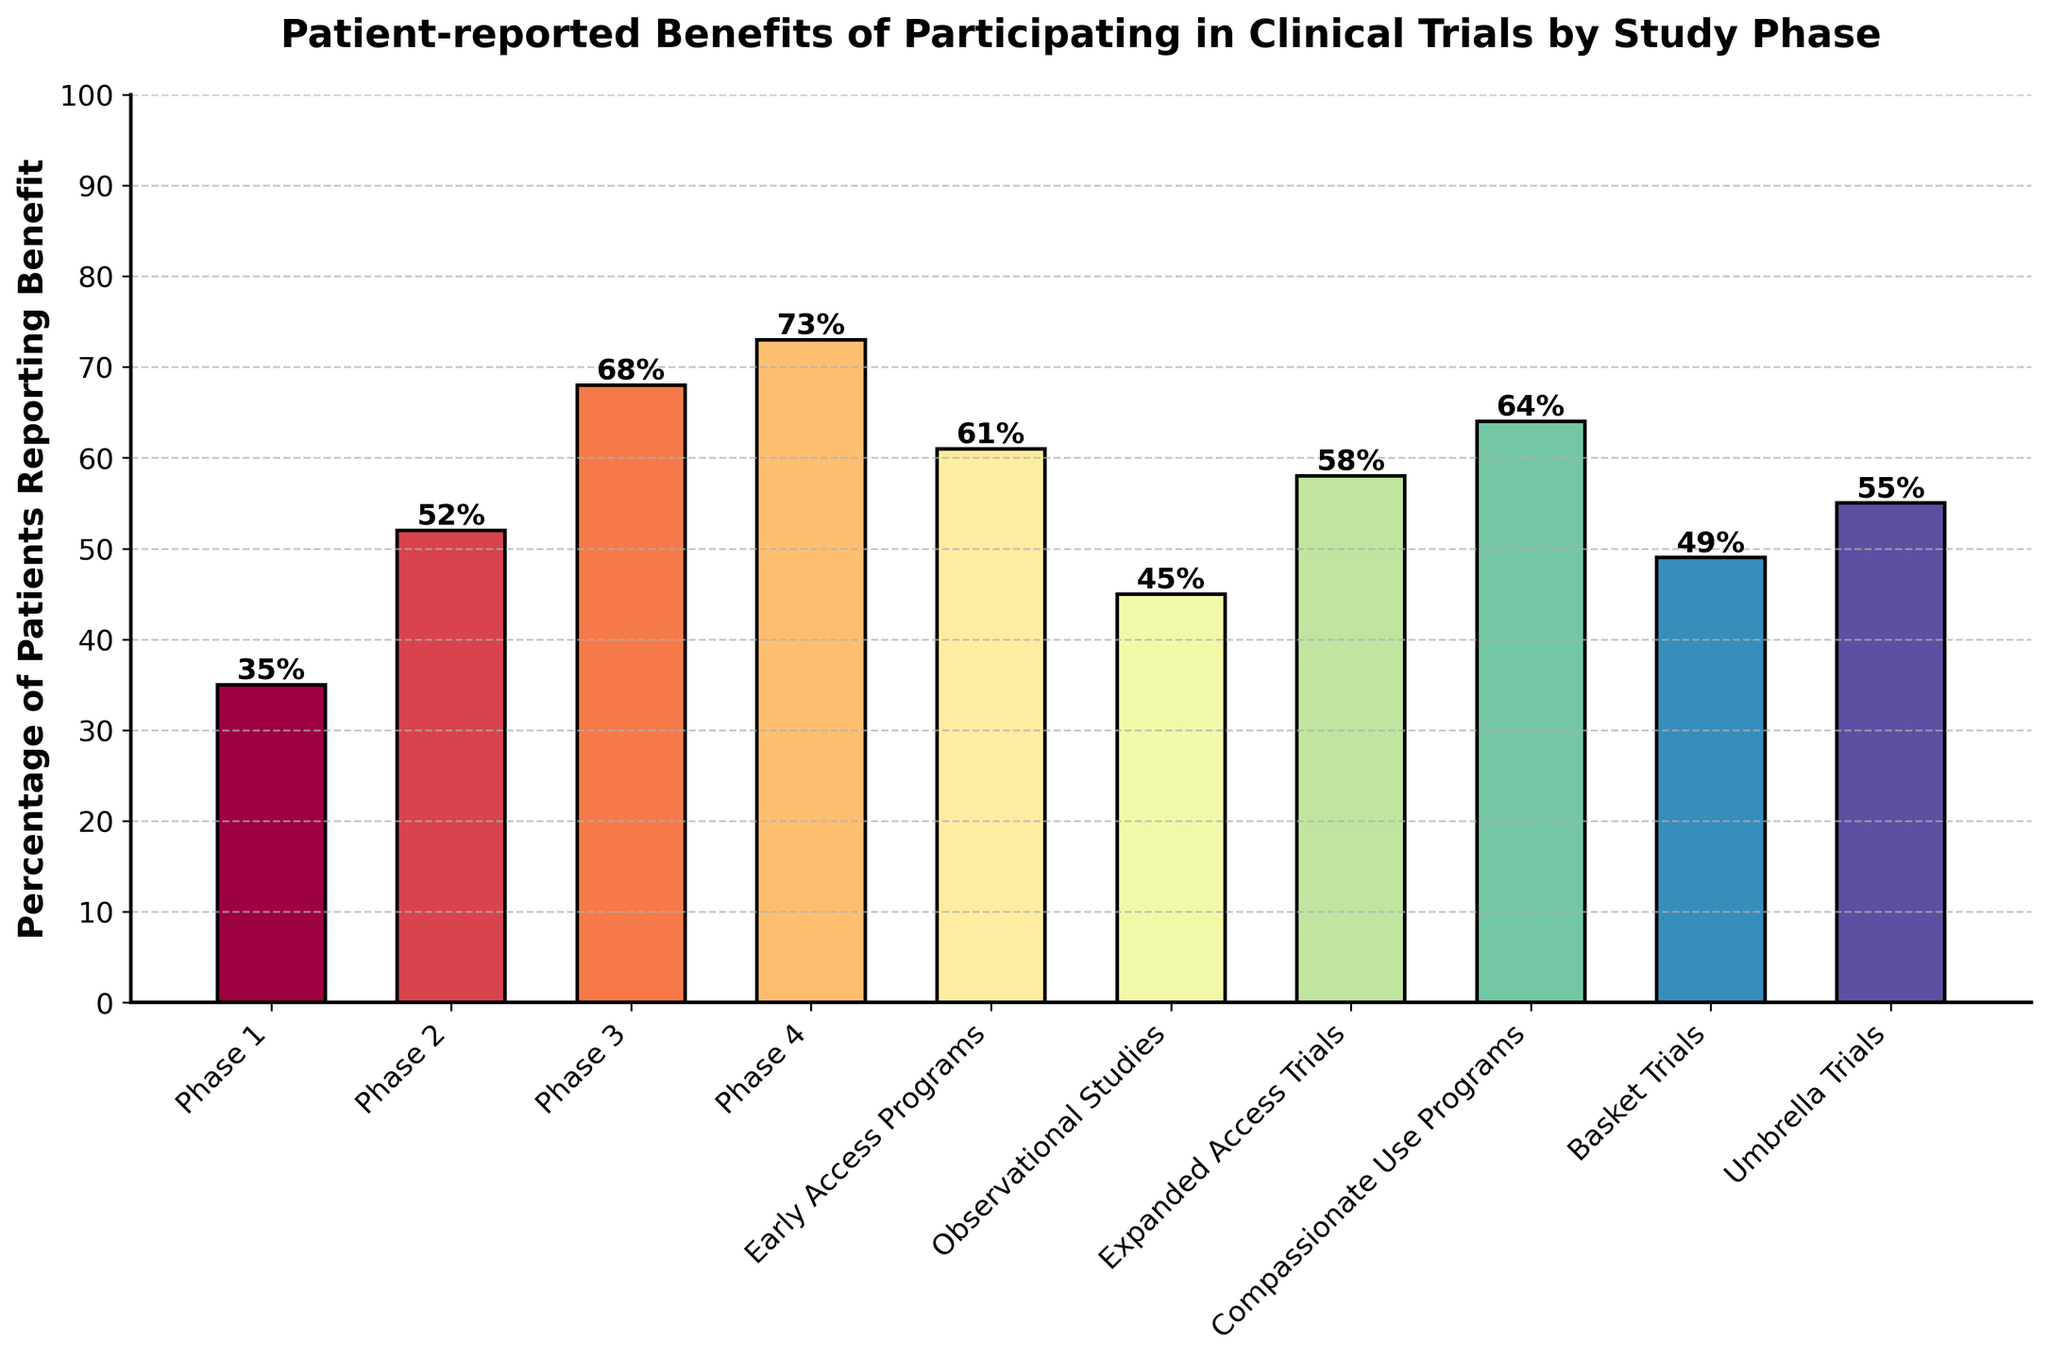What's the highest percentage of patients reporting a benefit by study phase? First, we look through the figure to identify the highest bar. The bar labeled "Phase 4" reaches 73%, which is the highest among all.
Answer: 73% Which study phase shows the lowest percentage of patients reporting a benefit? By examining the bar lengths, the shortest one is labeled "Phase 1," indicating the lowest percentage at 35%.
Answer: Phase 1 Is the percentage of patients reporting benefits in Phase 3 higher or lower than that in Expanded Access Trials? Compare the heights of the two bars. The Phase 3 bar reaches 68%, while the Expanded Access Trials bar reaches 58%. Hence, Phase 3 is higher.
Answer: Higher By how much does patient-reported benefit in Compassionate Use Programs exceed that in Basket Trials? The height of the Compassionate Use Programs bar is 64%, and that of Basket Trials is 49%. The difference is 64% - 49% = 15%.
Answer: 15% What is the average percentage of patients reporting benefits across all study phases? Sum all the percentages (35+52+68+73+61+45+58+64+49+55 = 560) and divide by the number of study phases (10). The average is 560 / 10 = 56%.
Answer: 56% How does the percentage of patients reporting benefits in Phase 2 compare to that in Umbrella Trials? Check the heights of the bars for Phase 2 and Umbrella Trials. Phase 2 stands at 52%, and Umbrella Trials at 55%. Phase 2 is slightly lower.
Answer: Lower What is the median percentage of patients reporting benefits across all study phases? First we list the percentages in ascending order: 35, 45, 49, 52, 55, 58, 61, 64, 68, 73. The median is the average of the 5th and 6th values: (55 + 58) / 2 = 56.5%.
Answer: 56.5% Which study phases have a percentage of patients reporting benefits above 60%? Identify the bars higher than the 60% mark. They are Phase 3 (68%), Phase 4 (73%), Expanded Access Trials (61%), and Compassionate Use Programs (64%).
Answer: Phase 3, Phase 4, Expanded Access Trials, Compassionate Use Programs How many study phases have over 50% of patients reporting benefits? Count the bars taller than the 50% mark. The study phases are Phase 2, Phase 3, Phase 4, Early Access Programs, Expanded Access Trials, Compassionate Use Programs, and Umbrella Trials. There are 7 in total.
Answer: 7 